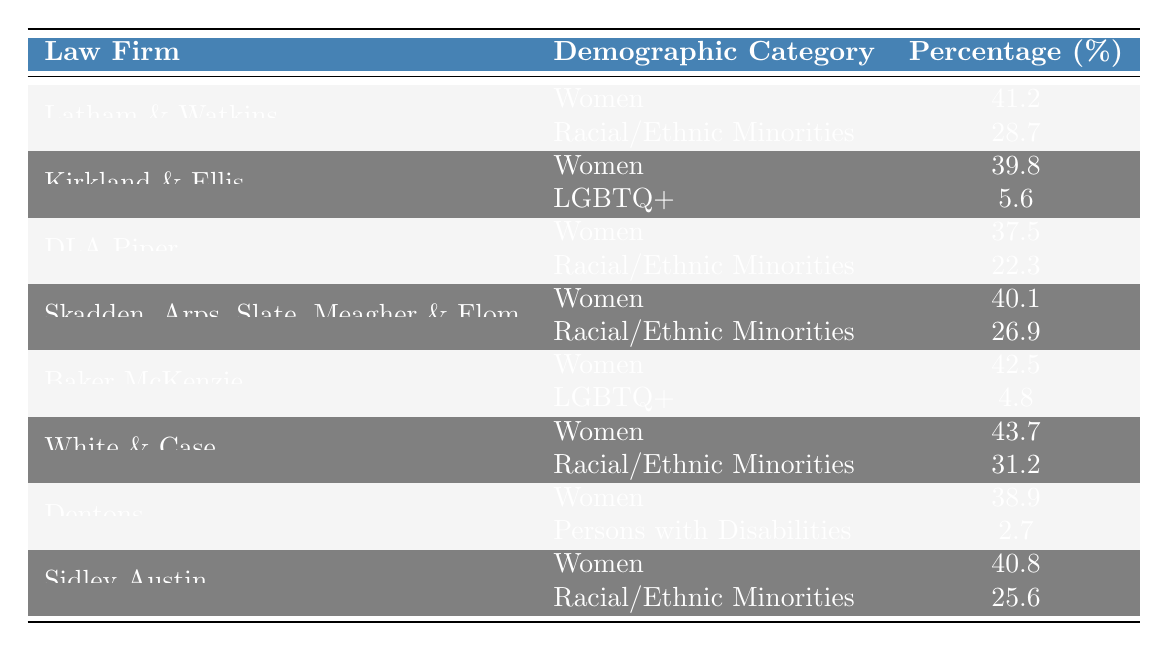What is the highest percentage of women at a law firm listed in the table? The highest percentage of women is found at White & Case, which has 43.7%.
Answer: 43.7% Which law firm has the lowest percentage of representation for LGBTQ+ individuals according to the table? The lowest percentage of representation for LGBTQ+ individuals is at Baker McKenzie with 4.8%.
Answer: 4.8% What is the average percentage of racial/ethnic minorities across the law firms listed? The percentages are 28.7 (Latham & Watkins), 22.3 (DLA Piper), 26.9 (Skadden, Arps, Slate, Meagher & Flom), 31.2 (White & Case), and 25.6 (Sidley Austin), totaling 134.7. The average is 134.7 / 5 = 26.94%.
Answer: 26.94% Is it true that DLA Piper has a higher percentage of women than Kirkland & Ellis? DLA Piper has 37.5% of women, while Kirkland & Ellis has 39.8%. Therefore, this statement is false.
Answer: No How many law firms have a higher percentage of women than Kirkland & Ellis? The law firms with higher percentages of women than Kirkland & Ellis (39.8%) are Latham & Watkins (41.2%), Baker McKenzie (42.5%), and White & Case (43.7%). This totals 3 law firms.
Answer: 3 What is the percentage difference in women representation between the highest (White & Case) and the lowest (DLA Piper) in the table? White & Case has 43.7% and DLA Piper has 37.5%. The difference is 43.7% - 37.5% = 6.2%.
Answer: 6.2% Which law firm has the best representation for racial/ethnic minorities among those listed? White & Case has the highest percentage of racial/ethnic minorities at 31.2%.
Answer: 31.2% If we only consider the law firms that report LGBTQ+ representation, what is the average percentage? The firms reporting LGBTQ+ are Kirkland & Ellis (5.6%) and Baker McKenzie (4.8%), giving a total of 10.4%. The average is 10.4 / 2 = 5.2%.
Answer: 5.2% Which demographic category has the highest overall average representation across all law firms? The average percentages for each group are: Women = (41.2 + 39.8 + 37.5 + 40.1 + 42.5 + 43.7 + 38.9 + 40.8) / 8 = 40.425%, Racial/Ethnic Minorities = (28.7 + 22.3 + 26.9 + 31.2 + 25.6) / 5 = 26.94%, LGBTQ+ = (5.6 + 4.8) / 2 = 5.2%. Women has the highest average at 40.425%.
Answer: Women Does Sidley Austin have a better representation of women than Dentons? Sidley Austin reports 40.8% women, while Dentons reports 38.9%, making this statement true.
Answer: Yes 